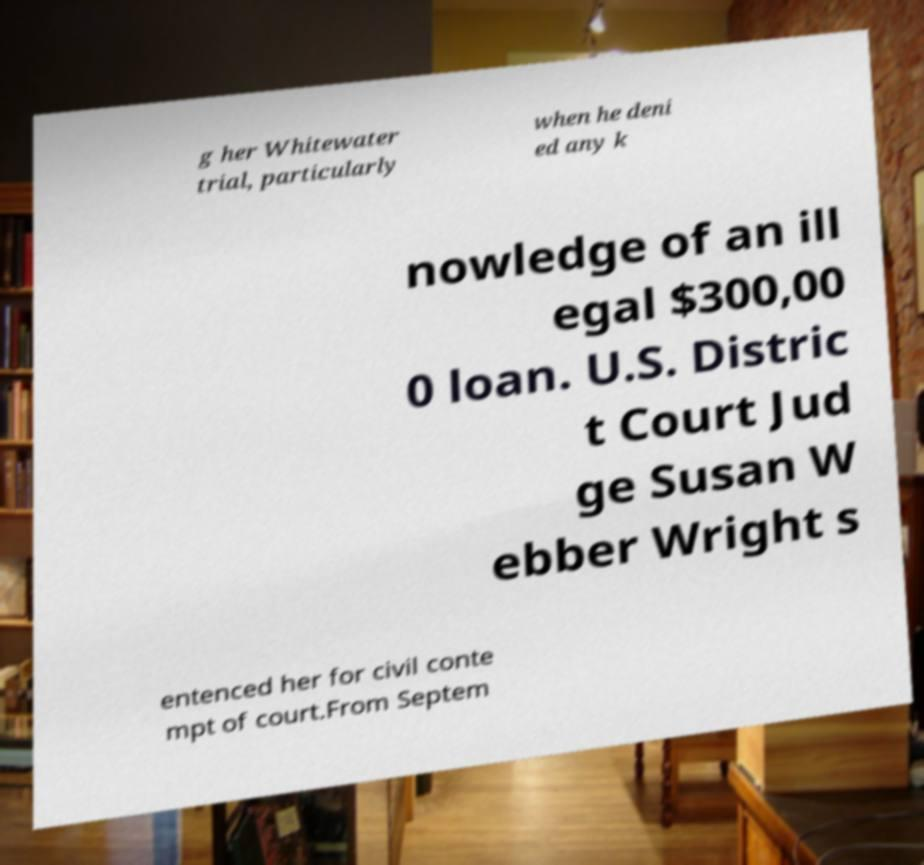For documentation purposes, I need the text within this image transcribed. Could you provide that? g her Whitewater trial, particularly when he deni ed any k nowledge of an ill egal $300,00 0 loan. U.S. Distric t Court Jud ge Susan W ebber Wright s entenced her for civil conte mpt of court.From Septem 